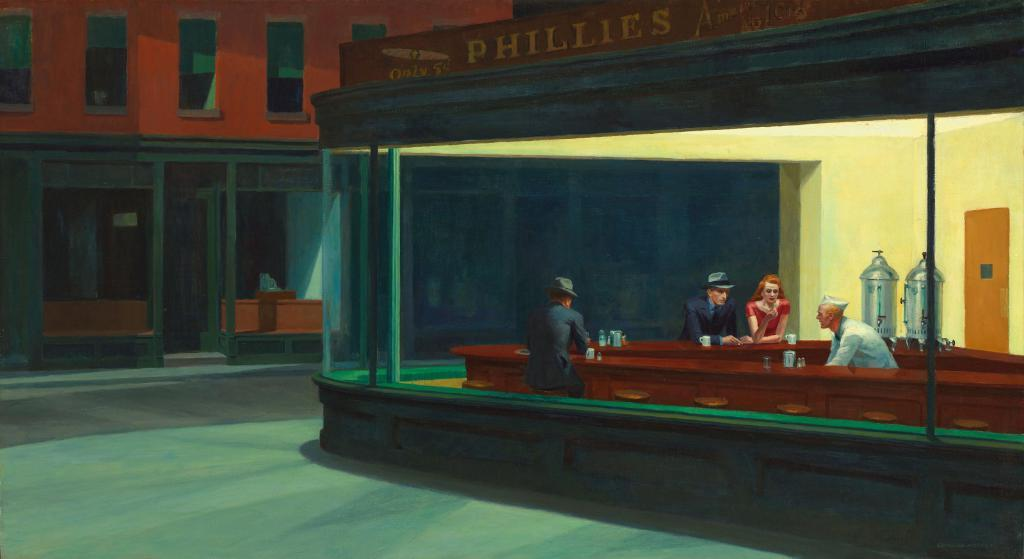What type of image is being described? The image is a drawing. What can be found in the drawing? There is a shop in the drawing. How many people are inside the shop? There are three men and a woman in the shop. What is located beside the shop in the drawing? There is a building beside the shop. What type of offer is the shop making to the woman in the drawing? There is no text or dialogue present in the drawing, so it is impossible to determine if the shop is making any offer to the woman. 